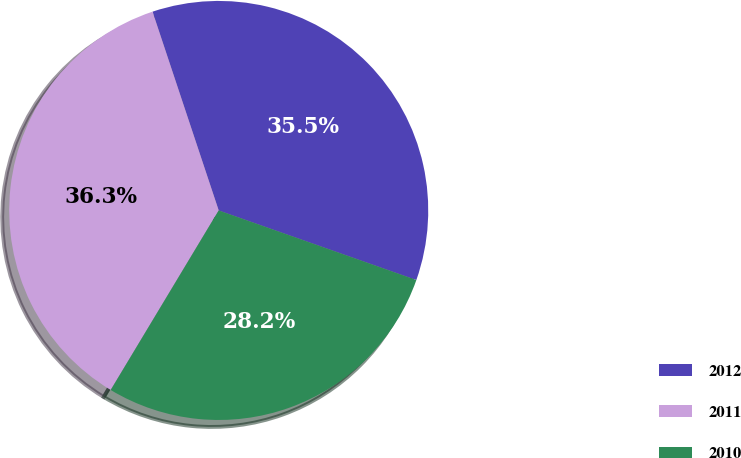Convert chart to OTSL. <chart><loc_0><loc_0><loc_500><loc_500><pie_chart><fcel>2012<fcel>2011<fcel>2010<nl><fcel>35.5%<fcel>36.26%<fcel>28.23%<nl></chart> 